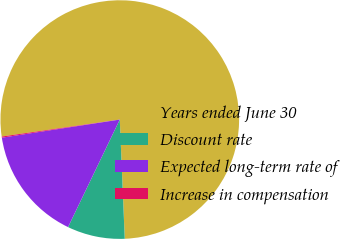<chart> <loc_0><loc_0><loc_500><loc_500><pie_chart><fcel>Years ended June 30<fcel>Discount rate<fcel>Expected long-term rate of<fcel>Increase in compensation<nl><fcel>76.61%<fcel>7.8%<fcel>15.44%<fcel>0.15%<nl></chart> 